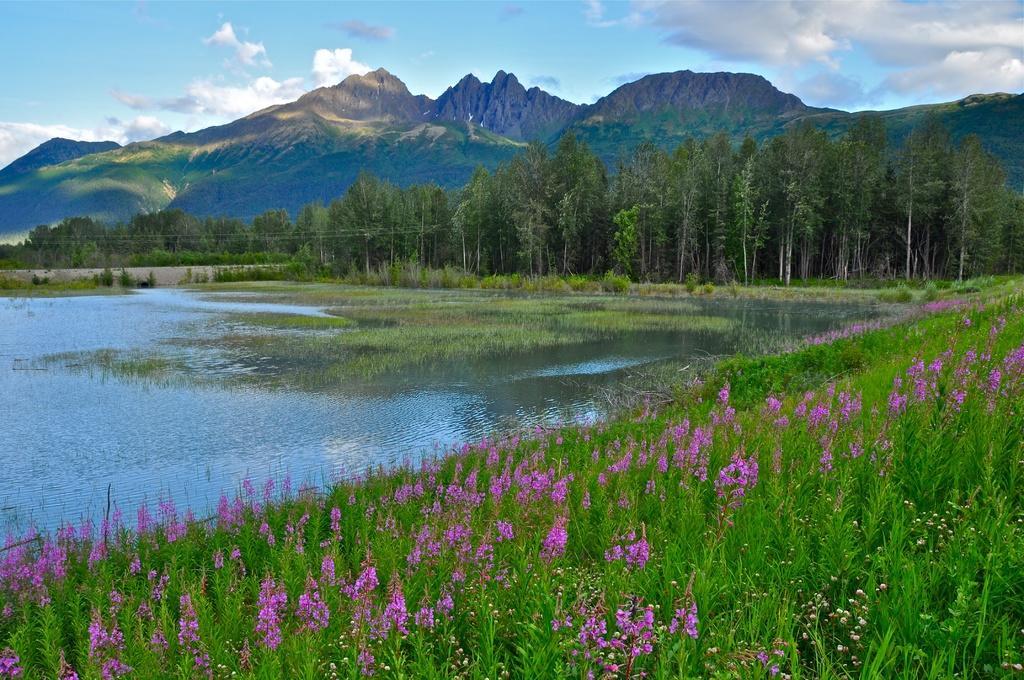Please provide a concise description of this image. This is an outside view. At the bottom there are few plants along with the flowers. On the left side there is a river. In the background there are many trees and hills. At the top of the image I can see the sky and clouds. 